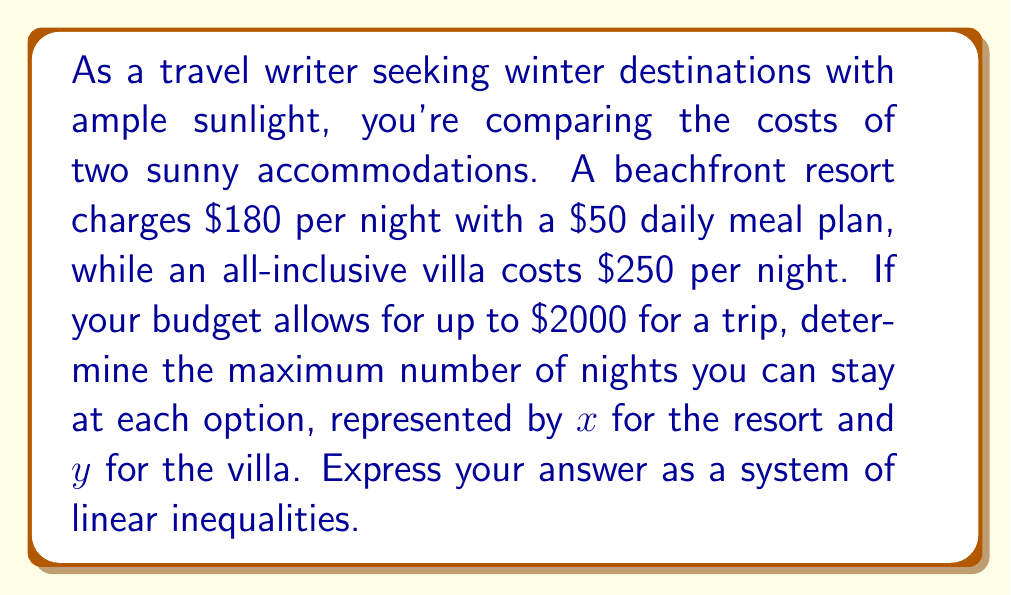What is the answer to this math problem? Let's approach this step-by-step:

1) First, let's set up the inequalities for each accommodation:

   For the resort: $230x \leq 2000$ (because $180 + $50 = $230 per night)
   For the villa: $250y \leq 2000$

2) We also need to consider that the number of nights must be non-negative:

   $x \geq 0$
   $y \geq 0$

3) To express the maximum number of nights for each option, we need to solve each inequality:

   For the resort: $230x \leq 2000$
                   $x \leq \frac{2000}{230} \approx 8.7$

   For the villa: $250y \leq 2000$
                  $y \leq \frac{2000}{250} = 8$

4) Since we're dealing with whole nights, we round down to the nearest integer:

   $x \leq 8$
   $y \leq 8$

5) Combining all these inequalities, we get our system:

   $$\begin{cases}
   230x \leq 2000 \\
   250y \leq 2000 \\
   x \geq 0 \\
   y \geq 0 \\
   x \leq 8 \\
   y \leq 8
   \end{cases}$$

This system of linear inequalities represents the maximum number of nights you can stay at each accommodation within your budget.
Answer: $$\begin{cases}
230x \leq 2000 \\
250y \leq 2000 \\
x \geq 0 \\
y \geq 0 \\
x \leq 8 \\
y \leq 8
\end{cases}$$ 